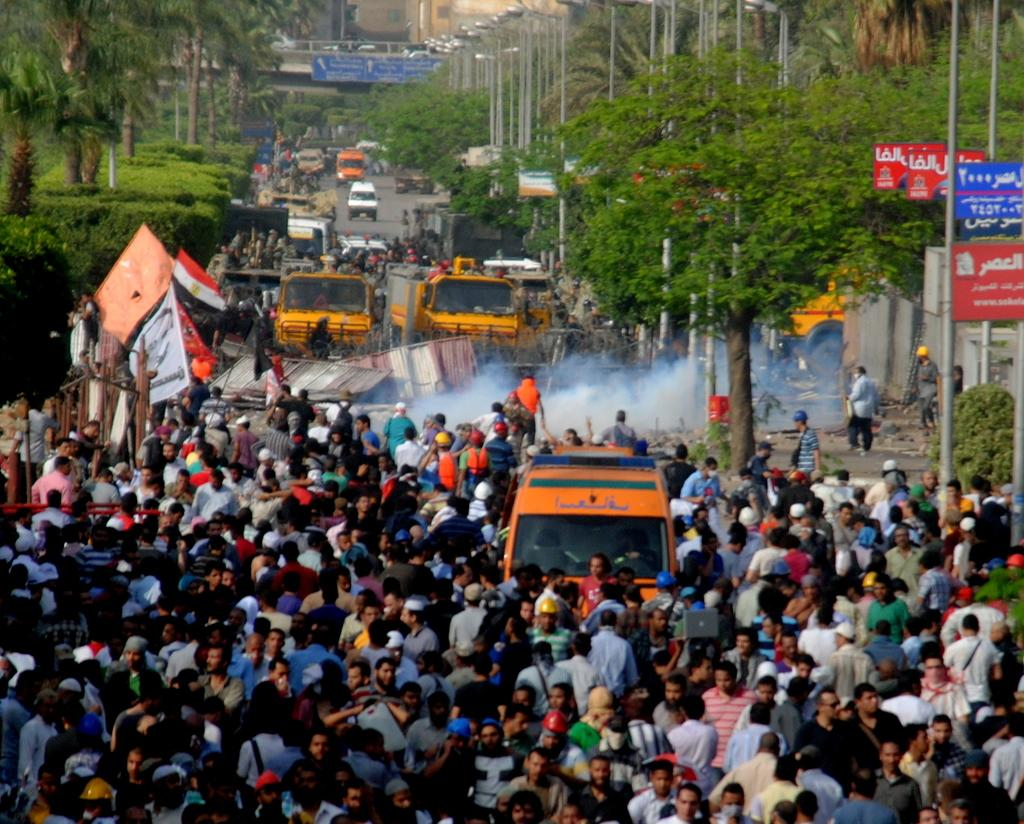What can be seen on the road in the image? There are vehicles and people on the road in the image. What else is visible in the image besides the road? There are trees and poles with flags visible in the image. Can you see any ghosts walking on the road in the image? There are no ghosts present in the image. Are there any lizards crawling on the trees in the image? There is no mention of lizards in the image, so we cannot determine if they are present or not. 